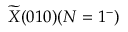Convert formula to latex. <formula><loc_0><loc_0><loc_500><loc_500>\widetilde { X } ( 0 1 0 ) ( N = 1 ^ { - } )</formula> 